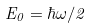Convert formula to latex. <formula><loc_0><loc_0><loc_500><loc_500>E _ { 0 } = \hbar { \omega } / 2</formula> 